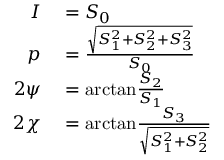<formula> <loc_0><loc_0><loc_500><loc_500>\begin{array} { r l } { I } & = S _ { 0 } } \\ { p } & = { \frac { \sqrt { S _ { 1 } ^ { 2 } + S _ { 2 } ^ { 2 } + S _ { 3 } ^ { 2 } } } { S _ { 0 } } } } \\ { 2 \psi } & = a r c t a n { \frac { S _ { 2 } } { S _ { 1 } } } } \\ { 2 \chi } & = a r c t a n { \frac { S _ { 3 } } { \sqrt { S _ { 1 } ^ { 2 } + S _ { 2 } ^ { 2 } } } } } \end{array}</formula> 